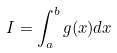<formula> <loc_0><loc_0><loc_500><loc_500>I = \int _ { a } ^ { b } g ( x ) d x</formula> 